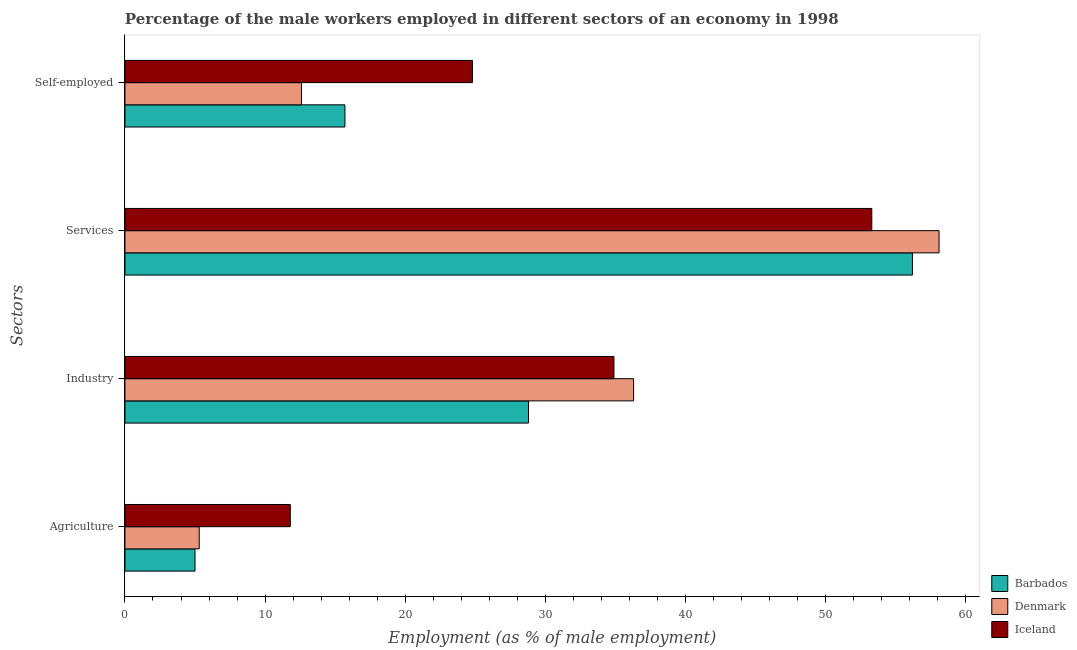How many different coloured bars are there?
Ensure brevity in your answer.  3. How many groups of bars are there?
Ensure brevity in your answer.  4. How many bars are there on the 1st tick from the bottom?
Offer a very short reply. 3. What is the label of the 3rd group of bars from the top?
Keep it short and to the point. Industry. What is the percentage of male workers in services in Denmark?
Ensure brevity in your answer.  58.1. Across all countries, what is the maximum percentage of male workers in services?
Your answer should be very brief. 58.1. Across all countries, what is the minimum percentage of self employed male workers?
Provide a short and direct response. 12.6. In which country was the percentage of male workers in agriculture maximum?
Provide a short and direct response. Iceland. What is the total percentage of male workers in agriculture in the graph?
Your response must be concise. 22.1. What is the difference between the percentage of self employed male workers in Barbados and that in Denmark?
Give a very brief answer. 3.1. What is the difference between the percentage of self employed male workers in Barbados and the percentage of male workers in services in Denmark?
Offer a very short reply. -42.4. What is the average percentage of male workers in industry per country?
Your answer should be compact. 33.33. What is the difference between the percentage of male workers in industry and percentage of male workers in services in Iceland?
Offer a very short reply. -18.4. In how many countries, is the percentage of male workers in services greater than 58 %?
Offer a terse response. 1. What is the ratio of the percentage of male workers in industry in Barbados to that in Denmark?
Make the answer very short. 0.79. Is the difference between the percentage of male workers in services in Barbados and Denmark greater than the difference between the percentage of self employed male workers in Barbados and Denmark?
Keep it short and to the point. No. What is the difference between the highest and the second highest percentage of male workers in agriculture?
Provide a succinct answer. 6.5. What is the difference between the highest and the lowest percentage of male workers in agriculture?
Your answer should be compact. 6.8. In how many countries, is the percentage of male workers in industry greater than the average percentage of male workers in industry taken over all countries?
Your response must be concise. 2. Is the sum of the percentage of self employed male workers in Barbados and Denmark greater than the maximum percentage of male workers in industry across all countries?
Your answer should be very brief. No. What does the 1st bar from the bottom in Self-employed represents?
Provide a succinct answer. Barbados. Is it the case that in every country, the sum of the percentage of male workers in agriculture and percentage of male workers in industry is greater than the percentage of male workers in services?
Your response must be concise. No. How many bars are there?
Give a very brief answer. 12. Are all the bars in the graph horizontal?
Give a very brief answer. Yes. How many countries are there in the graph?
Give a very brief answer. 3. What is the difference between two consecutive major ticks on the X-axis?
Your answer should be compact. 10. Where does the legend appear in the graph?
Your answer should be very brief. Bottom right. How many legend labels are there?
Give a very brief answer. 3. What is the title of the graph?
Ensure brevity in your answer.  Percentage of the male workers employed in different sectors of an economy in 1998. What is the label or title of the X-axis?
Your answer should be compact. Employment (as % of male employment). What is the label or title of the Y-axis?
Your answer should be very brief. Sectors. What is the Employment (as % of male employment) in Barbados in Agriculture?
Offer a terse response. 5. What is the Employment (as % of male employment) in Denmark in Agriculture?
Make the answer very short. 5.3. What is the Employment (as % of male employment) in Iceland in Agriculture?
Your answer should be very brief. 11.8. What is the Employment (as % of male employment) of Barbados in Industry?
Ensure brevity in your answer.  28.8. What is the Employment (as % of male employment) in Denmark in Industry?
Offer a terse response. 36.3. What is the Employment (as % of male employment) in Iceland in Industry?
Give a very brief answer. 34.9. What is the Employment (as % of male employment) of Barbados in Services?
Give a very brief answer. 56.2. What is the Employment (as % of male employment) of Denmark in Services?
Offer a terse response. 58.1. What is the Employment (as % of male employment) of Iceland in Services?
Ensure brevity in your answer.  53.3. What is the Employment (as % of male employment) in Barbados in Self-employed?
Make the answer very short. 15.7. What is the Employment (as % of male employment) of Denmark in Self-employed?
Provide a succinct answer. 12.6. What is the Employment (as % of male employment) of Iceland in Self-employed?
Make the answer very short. 24.8. Across all Sectors, what is the maximum Employment (as % of male employment) of Barbados?
Your answer should be very brief. 56.2. Across all Sectors, what is the maximum Employment (as % of male employment) of Denmark?
Keep it short and to the point. 58.1. Across all Sectors, what is the maximum Employment (as % of male employment) in Iceland?
Offer a very short reply. 53.3. Across all Sectors, what is the minimum Employment (as % of male employment) of Barbados?
Provide a short and direct response. 5. Across all Sectors, what is the minimum Employment (as % of male employment) in Denmark?
Keep it short and to the point. 5.3. Across all Sectors, what is the minimum Employment (as % of male employment) of Iceland?
Offer a terse response. 11.8. What is the total Employment (as % of male employment) of Barbados in the graph?
Provide a short and direct response. 105.7. What is the total Employment (as % of male employment) in Denmark in the graph?
Your answer should be compact. 112.3. What is the total Employment (as % of male employment) in Iceland in the graph?
Provide a short and direct response. 124.8. What is the difference between the Employment (as % of male employment) in Barbados in Agriculture and that in Industry?
Ensure brevity in your answer.  -23.8. What is the difference between the Employment (as % of male employment) in Denmark in Agriculture and that in Industry?
Provide a succinct answer. -31. What is the difference between the Employment (as % of male employment) in Iceland in Agriculture and that in Industry?
Ensure brevity in your answer.  -23.1. What is the difference between the Employment (as % of male employment) in Barbados in Agriculture and that in Services?
Provide a succinct answer. -51.2. What is the difference between the Employment (as % of male employment) of Denmark in Agriculture and that in Services?
Offer a very short reply. -52.8. What is the difference between the Employment (as % of male employment) in Iceland in Agriculture and that in Services?
Provide a short and direct response. -41.5. What is the difference between the Employment (as % of male employment) of Iceland in Agriculture and that in Self-employed?
Make the answer very short. -13. What is the difference between the Employment (as % of male employment) of Barbados in Industry and that in Services?
Provide a succinct answer. -27.4. What is the difference between the Employment (as % of male employment) of Denmark in Industry and that in Services?
Give a very brief answer. -21.8. What is the difference between the Employment (as % of male employment) in Iceland in Industry and that in Services?
Offer a terse response. -18.4. What is the difference between the Employment (as % of male employment) in Barbados in Industry and that in Self-employed?
Offer a very short reply. 13.1. What is the difference between the Employment (as % of male employment) of Denmark in Industry and that in Self-employed?
Keep it short and to the point. 23.7. What is the difference between the Employment (as % of male employment) of Iceland in Industry and that in Self-employed?
Your answer should be very brief. 10.1. What is the difference between the Employment (as % of male employment) of Barbados in Services and that in Self-employed?
Offer a very short reply. 40.5. What is the difference between the Employment (as % of male employment) in Denmark in Services and that in Self-employed?
Your answer should be compact. 45.5. What is the difference between the Employment (as % of male employment) of Barbados in Agriculture and the Employment (as % of male employment) of Denmark in Industry?
Provide a succinct answer. -31.3. What is the difference between the Employment (as % of male employment) of Barbados in Agriculture and the Employment (as % of male employment) of Iceland in Industry?
Make the answer very short. -29.9. What is the difference between the Employment (as % of male employment) in Denmark in Agriculture and the Employment (as % of male employment) in Iceland in Industry?
Provide a succinct answer. -29.6. What is the difference between the Employment (as % of male employment) of Barbados in Agriculture and the Employment (as % of male employment) of Denmark in Services?
Give a very brief answer. -53.1. What is the difference between the Employment (as % of male employment) of Barbados in Agriculture and the Employment (as % of male employment) of Iceland in Services?
Make the answer very short. -48.3. What is the difference between the Employment (as % of male employment) of Denmark in Agriculture and the Employment (as % of male employment) of Iceland in Services?
Ensure brevity in your answer.  -48. What is the difference between the Employment (as % of male employment) of Barbados in Agriculture and the Employment (as % of male employment) of Iceland in Self-employed?
Provide a succinct answer. -19.8. What is the difference between the Employment (as % of male employment) of Denmark in Agriculture and the Employment (as % of male employment) of Iceland in Self-employed?
Ensure brevity in your answer.  -19.5. What is the difference between the Employment (as % of male employment) in Barbados in Industry and the Employment (as % of male employment) in Denmark in Services?
Give a very brief answer. -29.3. What is the difference between the Employment (as % of male employment) of Barbados in Industry and the Employment (as % of male employment) of Iceland in Services?
Offer a terse response. -24.5. What is the difference between the Employment (as % of male employment) of Denmark in Industry and the Employment (as % of male employment) of Iceland in Services?
Offer a very short reply. -17. What is the difference between the Employment (as % of male employment) of Denmark in Industry and the Employment (as % of male employment) of Iceland in Self-employed?
Provide a succinct answer. 11.5. What is the difference between the Employment (as % of male employment) in Barbados in Services and the Employment (as % of male employment) in Denmark in Self-employed?
Provide a short and direct response. 43.6. What is the difference between the Employment (as % of male employment) of Barbados in Services and the Employment (as % of male employment) of Iceland in Self-employed?
Provide a short and direct response. 31.4. What is the difference between the Employment (as % of male employment) of Denmark in Services and the Employment (as % of male employment) of Iceland in Self-employed?
Keep it short and to the point. 33.3. What is the average Employment (as % of male employment) in Barbados per Sectors?
Keep it short and to the point. 26.43. What is the average Employment (as % of male employment) of Denmark per Sectors?
Ensure brevity in your answer.  28.07. What is the average Employment (as % of male employment) of Iceland per Sectors?
Offer a very short reply. 31.2. What is the difference between the Employment (as % of male employment) in Barbados and Employment (as % of male employment) in Denmark in Agriculture?
Your answer should be very brief. -0.3. What is the difference between the Employment (as % of male employment) in Denmark and Employment (as % of male employment) in Iceland in Agriculture?
Your answer should be compact. -6.5. What is the difference between the Employment (as % of male employment) in Barbados and Employment (as % of male employment) in Iceland in Industry?
Give a very brief answer. -6.1. What is the difference between the Employment (as % of male employment) of Denmark and Employment (as % of male employment) of Iceland in Industry?
Keep it short and to the point. 1.4. What is the difference between the Employment (as % of male employment) in Barbados and Employment (as % of male employment) in Iceland in Services?
Offer a very short reply. 2.9. What is the difference between the Employment (as % of male employment) in Denmark and Employment (as % of male employment) in Iceland in Services?
Provide a short and direct response. 4.8. What is the difference between the Employment (as % of male employment) in Denmark and Employment (as % of male employment) in Iceland in Self-employed?
Ensure brevity in your answer.  -12.2. What is the ratio of the Employment (as % of male employment) in Barbados in Agriculture to that in Industry?
Ensure brevity in your answer.  0.17. What is the ratio of the Employment (as % of male employment) in Denmark in Agriculture to that in Industry?
Provide a succinct answer. 0.15. What is the ratio of the Employment (as % of male employment) of Iceland in Agriculture to that in Industry?
Ensure brevity in your answer.  0.34. What is the ratio of the Employment (as % of male employment) of Barbados in Agriculture to that in Services?
Give a very brief answer. 0.09. What is the ratio of the Employment (as % of male employment) in Denmark in Agriculture to that in Services?
Offer a very short reply. 0.09. What is the ratio of the Employment (as % of male employment) of Iceland in Agriculture to that in Services?
Offer a terse response. 0.22. What is the ratio of the Employment (as % of male employment) in Barbados in Agriculture to that in Self-employed?
Provide a succinct answer. 0.32. What is the ratio of the Employment (as % of male employment) in Denmark in Agriculture to that in Self-employed?
Your answer should be very brief. 0.42. What is the ratio of the Employment (as % of male employment) in Iceland in Agriculture to that in Self-employed?
Offer a very short reply. 0.48. What is the ratio of the Employment (as % of male employment) in Barbados in Industry to that in Services?
Provide a succinct answer. 0.51. What is the ratio of the Employment (as % of male employment) of Denmark in Industry to that in Services?
Keep it short and to the point. 0.62. What is the ratio of the Employment (as % of male employment) of Iceland in Industry to that in Services?
Make the answer very short. 0.65. What is the ratio of the Employment (as % of male employment) in Barbados in Industry to that in Self-employed?
Your answer should be very brief. 1.83. What is the ratio of the Employment (as % of male employment) in Denmark in Industry to that in Self-employed?
Your answer should be very brief. 2.88. What is the ratio of the Employment (as % of male employment) of Iceland in Industry to that in Self-employed?
Your answer should be very brief. 1.41. What is the ratio of the Employment (as % of male employment) in Barbados in Services to that in Self-employed?
Offer a very short reply. 3.58. What is the ratio of the Employment (as % of male employment) in Denmark in Services to that in Self-employed?
Your answer should be compact. 4.61. What is the ratio of the Employment (as % of male employment) in Iceland in Services to that in Self-employed?
Your response must be concise. 2.15. What is the difference between the highest and the second highest Employment (as % of male employment) in Barbados?
Offer a terse response. 27.4. What is the difference between the highest and the second highest Employment (as % of male employment) in Denmark?
Your answer should be very brief. 21.8. What is the difference between the highest and the lowest Employment (as % of male employment) of Barbados?
Your response must be concise. 51.2. What is the difference between the highest and the lowest Employment (as % of male employment) in Denmark?
Give a very brief answer. 52.8. What is the difference between the highest and the lowest Employment (as % of male employment) in Iceland?
Provide a short and direct response. 41.5. 